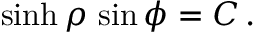<formula> <loc_0><loc_0><loc_500><loc_500>\sinh \rho \, \sin \phi = { C } \, .</formula> 